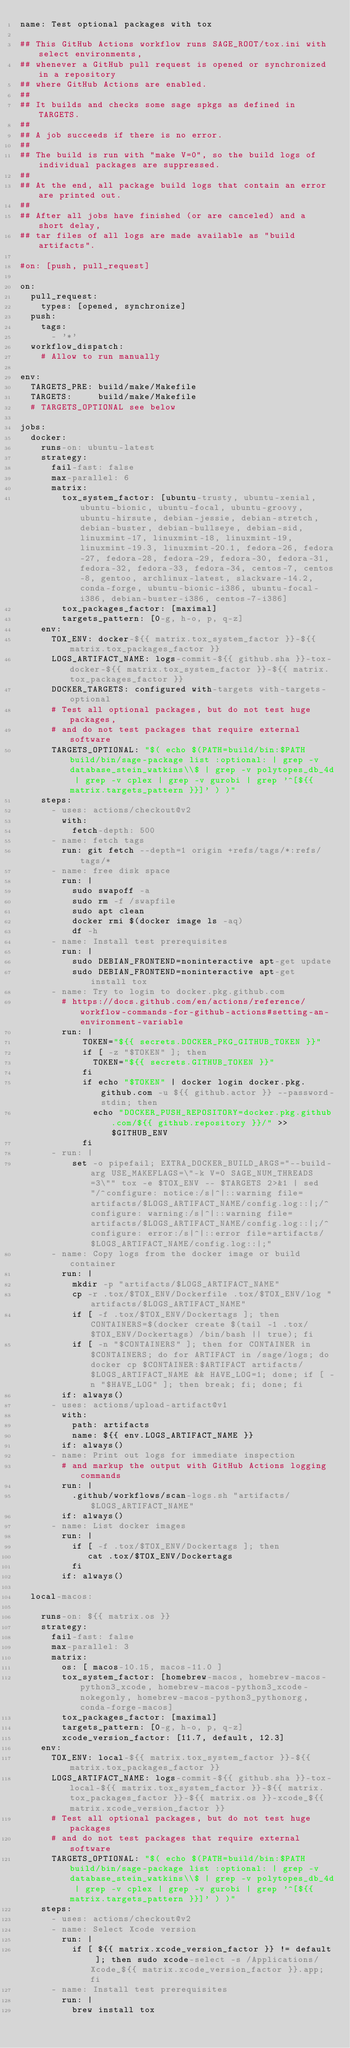<code> <loc_0><loc_0><loc_500><loc_500><_YAML_>name: Test optional packages with tox

## This GitHub Actions workflow runs SAGE_ROOT/tox.ini with select environments,
## whenever a GitHub pull request is opened or synchronized in a repository
## where GitHub Actions are enabled.
##
## It builds and checks some sage spkgs as defined in TARGETS.
##
## A job succeeds if there is no error.
##
## The build is run with "make V=0", so the build logs of individual packages are suppressed.
##
## At the end, all package build logs that contain an error are printed out.
##
## After all jobs have finished (or are canceled) and a short delay,
## tar files of all logs are made available as "build artifacts".

#on: [push, pull_request]

on:
  pull_request:
    types: [opened, synchronize]
  push:
    tags:
      - '*'
  workflow_dispatch:
    # Allow to run manually

env:
  TARGETS_PRE: build/make/Makefile
  TARGETS:     build/make/Makefile
  # TARGETS_OPTIONAL see below

jobs:
  docker:
    runs-on: ubuntu-latest
    strategy:
      fail-fast: false
      max-parallel: 6
      matrix:
        tox_system_factor: [ubuntu-trusty, ubuntu-xenial, ubuntu-bionic, ubuntu-focal, ubuntu-groovy, ubuntu-hirsute, debian-jessie, debian-stretch, debian-buster, debian-bullseye, debian-sid, linuxmint-17, linuxmint-18, linuxmint-19, linuxmint-19.3, linuxmint-20.1, fedora-26, fedora-27, fedora-28, fedora-29, fedora-30, fedora-31, fedora-32, fedora-33, fedora-34, centos-7, centos-8, gentoo, archlinux-latest, slackware-14.2, conda-forge, ubuntu-bionic-i386, ubuntu-focal-i386, debian-buster-i386, centos-7-i386]
        tox_packages_factor: [maximal]
        targets_pattern: [0-g, h-o, p, q-z]
    env:
      TOX_ENV: docker-${{ matrix.tox_system_factor }}-${{ matrix.tox_packages_factor }}
      LOGS_ARTIFACT_NAME: logs-commit-${{ github.sha }}-tox-docker-${{ matrix.tox_system_factor }}-${{ matrix.tox_packages_factor }}
      DOCKER_TARGETS: configured with-targets with-targets-optional
      # Test all optional packages, but do not test huge packages,
      # and do not test packages that require external software
      TARGETS_OPTIONAL: "$( echo $(PATH=build/bin:$PATH build/bin/sage-package list :optional: | grep -v  database_stein_watkins\\$ | grep -v polytopes_db_4d | grep -v cplex | grep -v gurobi | grep '^[${{ matrix.targets_pattern }}]' ) )"
    steps:
      - uses: actions/checkout@v2
        with:
          fetch-depth: 500
      - name: fetch tags
        run: git fetch --depth=1 origin +refs/tags/*:refs/tags/*
      - name: free disk space
        run: |
          sudo swapoff -a
          sudo rm -f /swapfile
          sudo apt clean
          docker rmi $(docker image ls -aq)
          df -h
      - name: Install test prerequisites
        run: |
          sudo DEBIAN_FRONTEND=noninteractive apt-get update
          sudo DEBIAN_FRONTEND=noninteractive apt-get install tox
      - name: Try to login to docker.pkg.github.com
        # https://docs.github.com/en/actions/reference/workflow-commands-for-github-actions#setting-an-environment-variable
        run: |
            TOKEN="${{ secrets.DOCKER_PKG_GITHUB_TOKEN }}"
            if [ -z "$TOKEN" ]; then
              TOKEN="${{ secrets.GITHUB_TOKEN }}"
            fi
            if echo "$TOKEN" | docker login docker.pkg.github.com -u ${{ github.actor }} --password-stdin; then
              echo "DOCKER_PUSH_REPOSITORY=docker.pkg.github.com/${{ github.repository }}/" >> $GITHUB_ENV
            fi
      - run: |
          set -o pipefail; EXTRA_DOCKER_BUILD_ARGS="--build-arg USE_MAKEFLAGS=\"-k V=0 SAGE_NUM_THREADS=3\"" tox -e $TOX_ENV -- $TARGETS 2>&1 | sed "/^configure: notice:/s|^|::warning file=artifacts/$LOGS_ARTIFACT_NAME/config.log::|;/^configure: warning:/s|^|::warning file=artifacts/$LOGS_ARTIFACT_NAME/config.log::|;/^configure: error:/s|^|::error file=artifacts/$LOGS_ARTIFACT_NAME/config.log::|;"
      - name: Copy logs from the docker image or build container
        run: |
          mkdir -p "artifacts/$LOGS_ARTIFACT_NAME"
          cp -r .tox/$TOX_ENV/Dockerfile .tox/$TOX_ENV/log "artifacts/$LOGS_ARTIFACT_NAME"
          if [ -f .tox/$TOX_ENV/Dockertags ]; then CONTAINERS=$(docker create $(tail -1 .tox/$TOX_ENV/Dockertags) /bin/bash || true); fi
          if [ -n "$CONTAINERS" ]; then for CONTAINER in $CONTAINERS; do for ARTIFACT in /sage/logs; do docker cp $CONTAINER:$ARTIFACT artifacts/$LOGS_ARTIFACT_NAME && HAVE_LOG=1; done; if [ -n "$HAVE_LOG" ]; then break; fi; done; fi
        if: always()
      - uses: actions/upload-artifact@v1
        with:
          path: artifacts
          name: ${{ env.LOGS_ARTIFACT_NAME }}
        if: always()
      - name: Print out logs for immediate inspection
        # and markup the output with GitHub Actions logging commands
        run: |
          .github/workflows/scan-logs.sh "artifacts/$LOGS_ARTIFACT_NAME"
        if: always()
      - name: List docker images
        run: |
          if [ -f .tox/$TOX_ENV/Dockertags ]; then
             cat .tox/$TOX_ENV/Dockertags
          fi
        if: always()

  local-macos:

    runs-on: ${{ matrix.os }}
    strategy:
      fail-fast: false
      max-parallel: 3
      matrix:
        os: [ macos-10.15, macos-11.0 ]
        tox_system_factor: [homebrew-macos, homebrew-macos-python3_xcode, homebrew-macos-python3_xcode-nokegonly, homebrew-macos-python3_pythonorg, conda-forge-macos]
        tox_packages_factor: [maximal]
        targets_pattern: [0-g, h-o, p, q-z]
        xcode_version_factor: [11.7, default, 12.3]
    env:
      TOX_ENV: local-${{ matrix.tox_system_factor }}-${{ matrix.tox_packages_factor }}
      LOGS_ARTIFACT_NAME: logs-commit-${{ github.sha }}-tox-local-${{ matrix.tox_system_factor }}-${{ matrix.tox_packages_factor }}-${{ matrix.os }}-xcode_${{ matrix.xcode_version_factor }}
      # Test all optional packages, but do not test huge packages
      # and do not test packages that require external software
      TARGETS_OPTIONAL: "$( echo $(PATH=build/bin:$PATH build/bin/sage-package list :optional: | grep -v  database_stein_watkins\\$ | grep -v polytopes_db_4d | grep -v cplex | grep -v gurobi | grep '^[${{ matrix.targets_pattern }}]' ) )"
    steps:
      - uses: actions/checkout@v2
      - name: Select Xcode version
        run: |
          if [ ${{ matrix.xcode_version_factor }} != default ]; then sudo xcode-select -s /Applications/Xcode_${{ matrix.xcode_version_factor }}.app; fi
      - name: Install test prerequisites
        run: |
          brew install tox</code> 